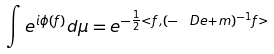<formula> <loc_0><loc_0><loc_500><loc_500>\int e ^ { i \phi ( f ) } d \mu = e ^ { - \frac { 1 } { 2 } < f , ( - \ D e + m ) ^ { - 1 } f > }</formula> 